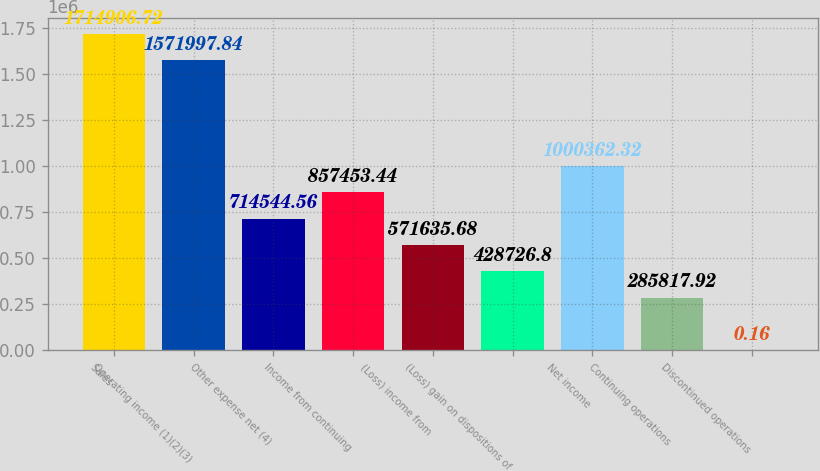Convert chart to OTSL. <chart><loc_0><loc_0><loc_500><loc_500><bar_chart><fcel>Sales<fcel>Operating income (1)(2)(3)<fcel>Other expense net (4)<fcel>Income from continuing<fcel>(Loss) income from<fcel>(Loss) gain on dispositions of<fcel>Net income<fcel>Continuing operations<fcel>Discontinued operations<nl><fcel>1.71491e+06<fcel>1.572e+06<fcel>714545<fcel>857453<fcel>571636<fcel>428727<fcel>1.00036e+06<fcel>285818<fcel>0.16<nl></chart> 